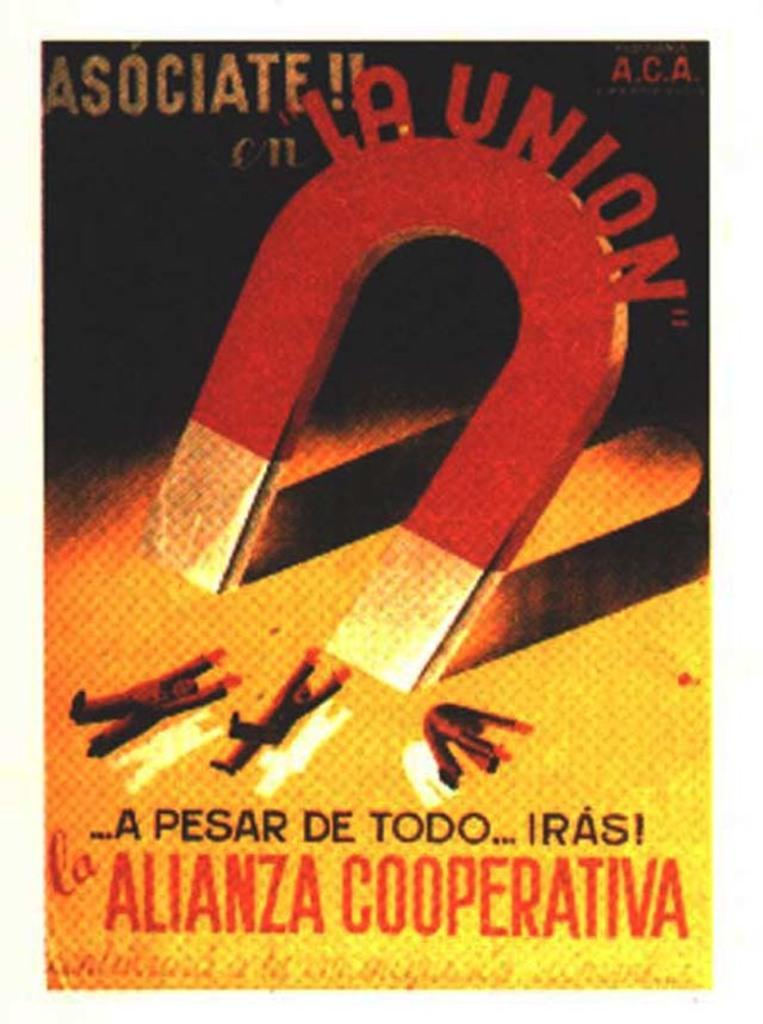<image>
Describe the image concisely. A book cover with a huge magnet that says La Union on it. 